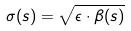<formula> <loc_0><loc_0><loc_500><loc_500>\sigma ( s ) = \sqrt { \epsilon \cdot \beta ( s ) }</formula> 